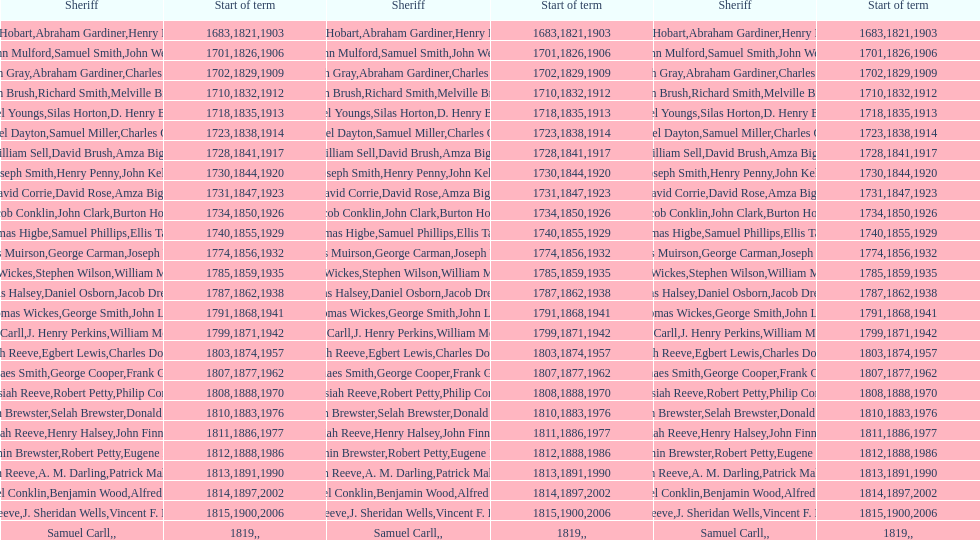Could you parse the entire table as a dict? {'header': ['Sheriff', 'Start of term', 'Sheriff', 'Start of term', 'Sheriff', 'Start of term'], 'rows': [['Josiah Hobart', '1683', 'Abraham Gardiner', '1821', 'Henry Preston', '1903'], ['John Mulford', '1701', 'Samuel Smith', '1826', 'John Wells', '1906'], ['Hugh Gray', '1702', 'Abraham Gardiner', '1829', 'Charles Platt', '1909'], ['John Brush', '1710', 'Richard Smith', '1832', 'Melville Brush', '1912'], ['Daniel Youngs', '1718', 'Silas Horton', '1835', 'D. Henry Brown', '1913'], ['Samuel Dayton', '1723', 'Samuel Miller', '1838', "Charles O'Dell", '1914'], ['William Sell', '1728', 'David Brush', '1841', 'Amza Biggs', '1917'], ['Joseph Smith', '1730', 'Henry Penny', '1844', 'John Kelly', '1920'], ['David Corrie', '1731', 'David Rose', '1847', 'Amza Biggs', '1923'], ['Jacob Conklin', '1734', 'John Clark', '1850', 'Burton Howe', '1926'], ['Thomas Higbe', '1740', 'Samuel Phillips', '1855', 'Ellis Taylor', '1929'], ['James Muirson', '1774', 'George Carman', '1856', 'Joseph Warta', '1932'], ['Thomas Wickes', '1785', 'Stephen Wilson', '1859', 'William McCollom', '1935'], ['Silas Halsey', '1787', 'Daniel Osborn', '1862', 'Jacob Dreyer', '1938'], ['Thomas Wickes', '1791', 'George Smith', '1868', 'John Levy', '1941'], ['Phinaes Carll', '1799', 'J. Henry Perkins', '1871', 'William McCollom', '1942'], ['Josiah Reeve', '1803', 'Egbert Lewis', '1874', 'Charles Dominy', '1957'], ['Phinaes Smith', '1807', 'George Cooper', '1877', 'Frank Gross', '1962'], ['Josiah Reeve', '1808', 'Robert Petty', '1888', 'Philip Corso', '1970'], ['Benjamin Brewster', '1810', 'Selah Brewster', '1883', 'Donald Dilworth', '1976'], ['Josiah Reeve', '1811', 'Henry Halsey', '1886', 'John Finnerty', '1977'], ['Benjamin Brewster', '1812', 'Robert Petty', '1888', 'Eugene Dooley', '1986'], ['Josiah Reeve', '1813', 'A. M. Darling', '1891', 'Patrick Mahoney', '1990'], ['Nathaniel Conklin', '1814', 'Benjamin Wood', '1897', 'Alfred C. Tisch', '2002'], ['Josiah Reeve', '1815', 'J. Sheridan Wells', '1900', 'Vincent F. DeMarco', '2006'], ['Samuel Carll', '1819', '', '', '', '']]} How many law enforcement officers with the last name biggs hold the title of sheriff? 1. 